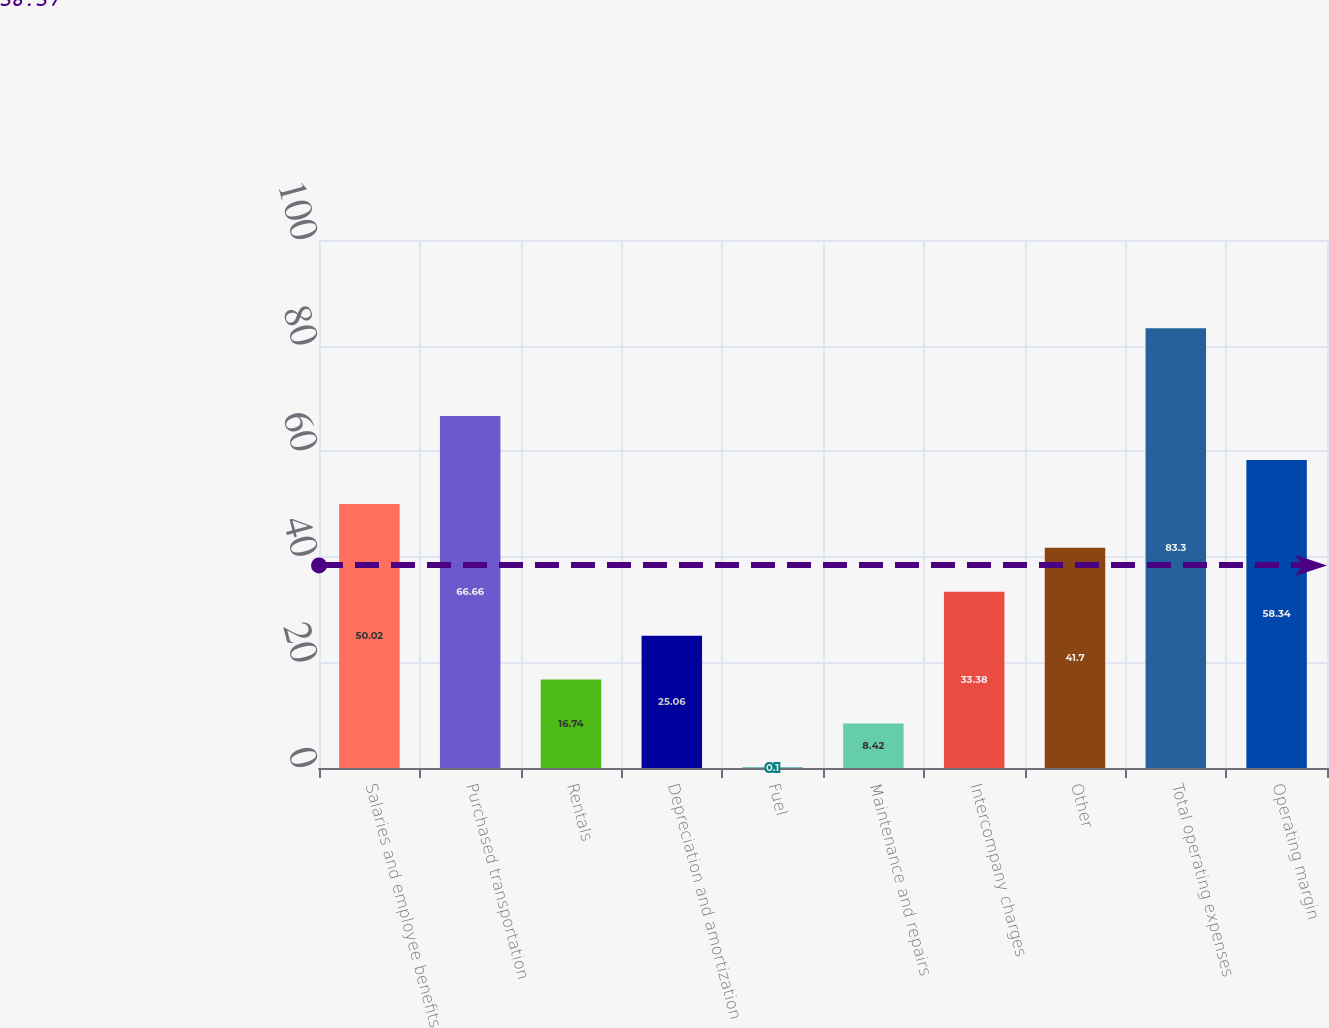<chart> <loc_0><loc_0><loc_500><loc_500><bar_chart><fcel>Salaries and employee benefits<fcel>Purchased transportation<fcel>Rentals<fcel>Depreciation and amortization<fcel>Fuel<fcel>Maintenance and repairs<fcel>Intercompany charges<fcel>Other<fcel>Total operating expenses<fcel>Operating margin<nl><fcel>50.02<fcel>66.66<fcel>16.74<fcel>25.06<fcel>0.1<fcel>8.42<fcel>33.38<fcel>41.7<fcel>83.3<fcel>58.34<nl></chart> 